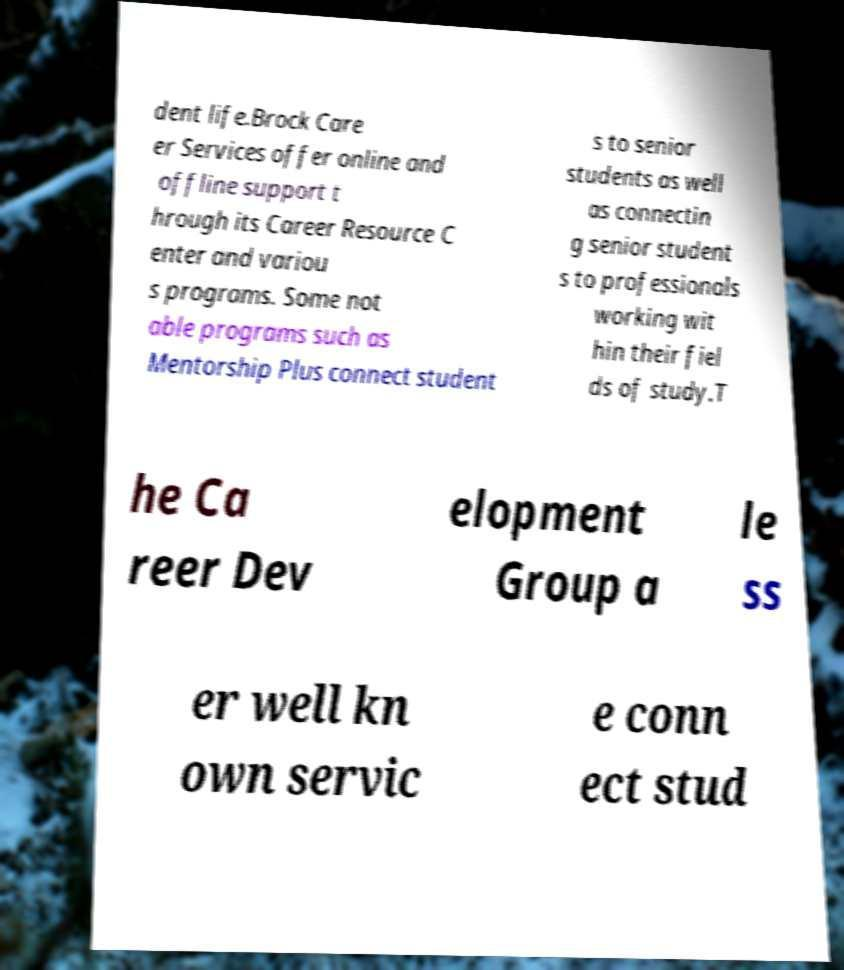For documentation purposes, I need the text within this image transcribed. Could you provide that? dent life.Brock Care er Services offer online and offline support t hrough its Career Resource C enter and variou s programs. Some not able programs such as Mentorship Plus connect student s to senior students as well as connectin g senior student s to professionals working wit hin their fiel ds of study.T he Ca reer Dev elopment Group a le ss er well kn own servic e conn ect stud 